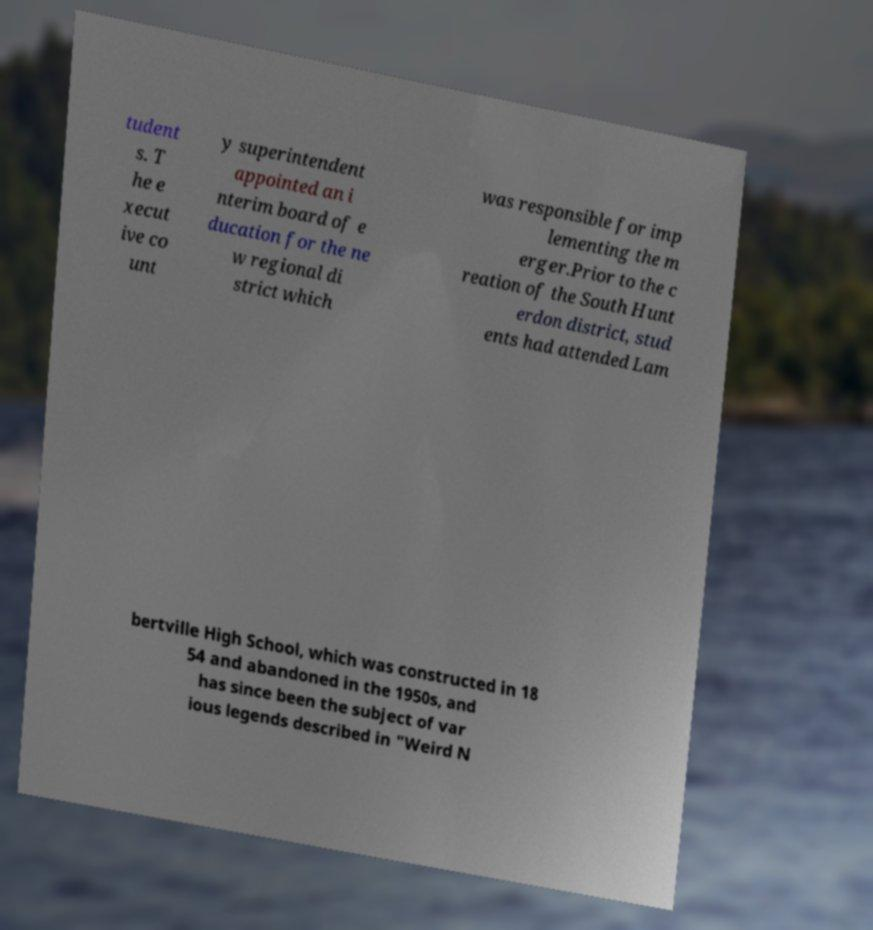Could you extract and type out the text from this image? tudent s. T he e xecut ive co unt y superintendent appointed an i nterim board of e ducation for the ne w regional di strict which was responsible for imp lementing the m erger.Prior to the c reation of the South Hunt erdon district, stud ents had attended Lam bertville High School, which was constructed in 18 54 and abandoned in the 1950s, and has since been the subject of var ious legends described in "Weird N 